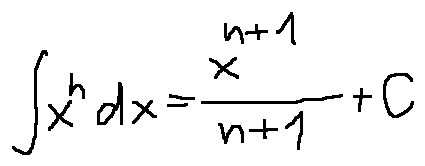<formula> <loc_0><loc_0><loc_500><loc_500>\int x ^ { n } d x = \frac { x ^ { n + 1 } } { n + 1 } + C</formula> 